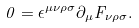Convert formula to latex. <formula><loc_0><loc_0><loc_500><loc_500>0 = \epsilon ^ { \mu \nu \rho \sigma } \partial _ { \mu } F _ { \nu \rho \sigma } .</formula> 